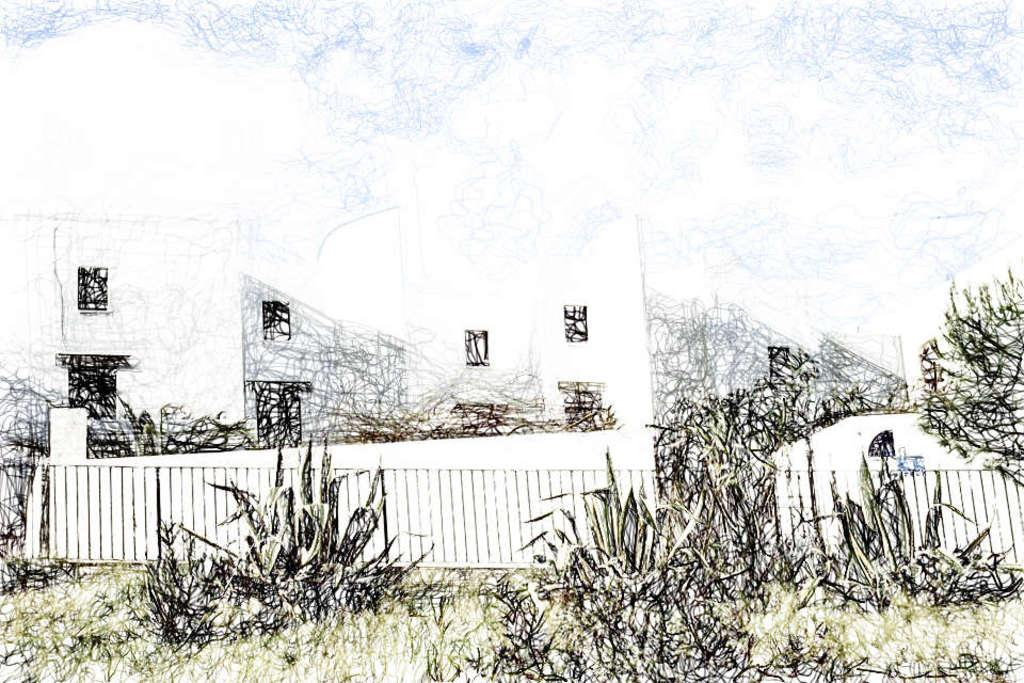What is the main subject of the sketch? The sketch depicts a building. What type of natural elements are present in the sketch? There are trees and plants in the sketch. What type of barrier can be seen in the sketch? There is a fence in the sketch. What type of cup is being used by the minister in the sketch? There is no cup or minister present in the sketch; it only depicts a building, trees, plants, and a fence. 